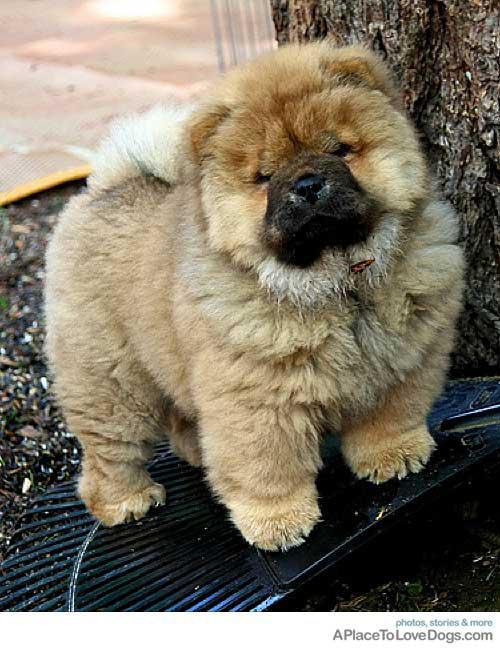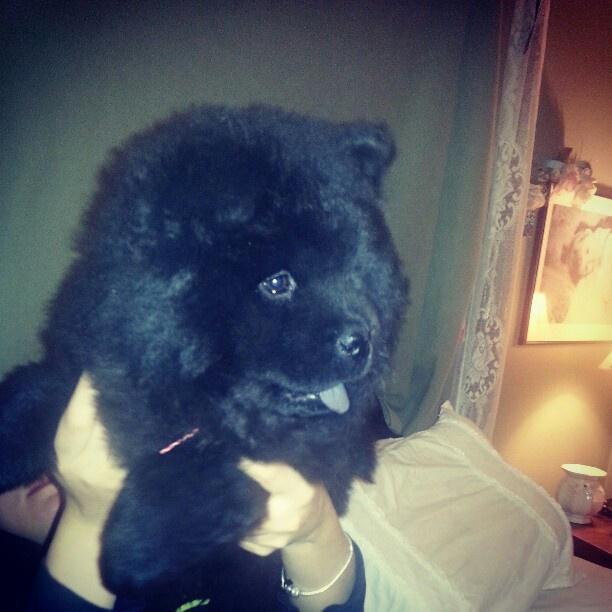The first image is the image on the left, the second image is the image on the right. For the images shown, is this caption "A person holds up a chow puppy in the left image, and the right image features a black chow puppy in front of a metal fence-like barrier." true? Answer yes or no. No. The first image is the image on the left, the second image is the image on the right. Evaluate the accuracy of this statement regarding the images: "One image in the pair shows a single black dog and the other shows a single tan dog.". Is it true? Answer yes or no. Yes. 